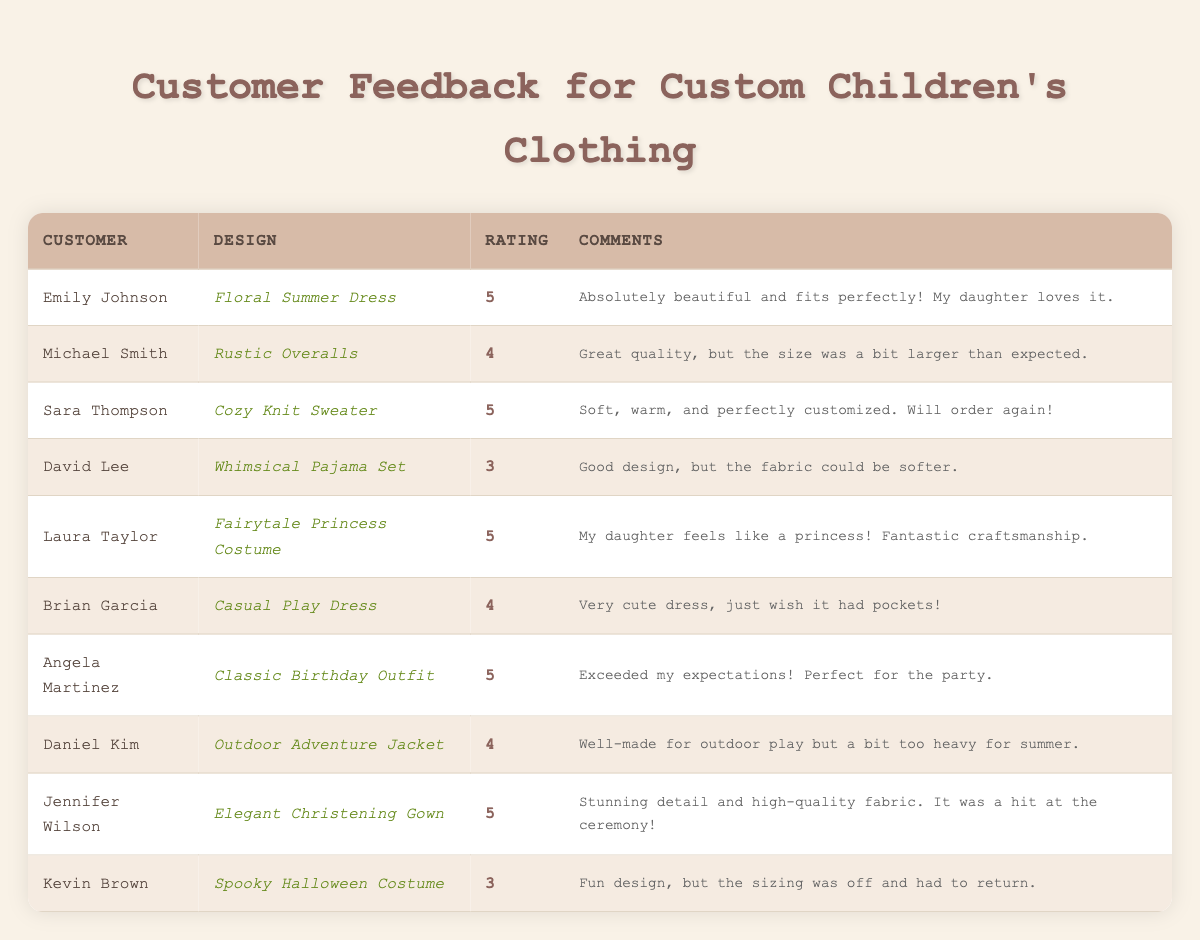What is the highest rating given and by whom? The highest rating in the table is 5. It was given by Emily Johnson for the "Floral Summer Dress".
Answer: Emily Johnson How many designs received a rating of 5? There are five designs listed in the table that received a rating of 5, which includes the designs by Emily Johnson, Sara Thompson, Laura Taylor, Angela Martinez, and Jennifer Wilson.
Answer: 5 What is the average rating for all designs? The sum of all ratings is (5 + 4 + 5 + 3 + 5 + 4 + 5 + 4 + 5 + 3) = 47, and there are 10 designs. The average rating is 47 / 10 = 4.7.
Answer: 4.7 Which design had the most critical feedback? The "Whimsical Pajama Set" from David Lee and the "Spooky Halloween Costume" from Kevin Brown both received the lowest rating of 3.
Answer: Whimsical Pajama Set and Spooky Halloween Costume Did any customer comment about a specific improvement needed? Yes, Brian Garcia mentioned he wished the "Casual Play Dress" had pockets, indicating a desire for a specific feature.
Answer: Yes Which design received feedback about fabric softness? The "Whimsical Pajama Set" received feedback from David Lee, who commented that "the fabric could be softer."
Answer: Whimsical Pajama Set Is there any design rated below 4? Yes, both the "Whimsical Pajama Set" and the "Spooky Halloween Costume" were rated 3, which is below 4.
Answer: Yes Which customers left feedback with a rating of 4? The customers who left feedback with a rating of 4 are Michael Smith, Brian Garcia, and Daniel Kim for their respective designs.
Answer: 3 customers What percentage of designs received a rating of 4 or higher? There are 10 designs total, and 7 of them received a rating of 4 or higher (Emily Johnson, Michael Smith, Sara Thompson, Laura Taylor, Brian Garcia, Angela Martinez, Daniel Kim). To calculate the percentage: (7 / 10) * 100 = 70%.
Answer: 70% Was there any comment praising craftsmanship? Yes, Laura Taylor's feedback for the "Fairytale Princess Costume" praised the craftsmanship by stating, "Fantastic craftsmanship."
Answer: Yes How many customers provided feedback in total? The table shows feedback from a total of 10 customers listed in the customer feedback section.
Answer: 10 